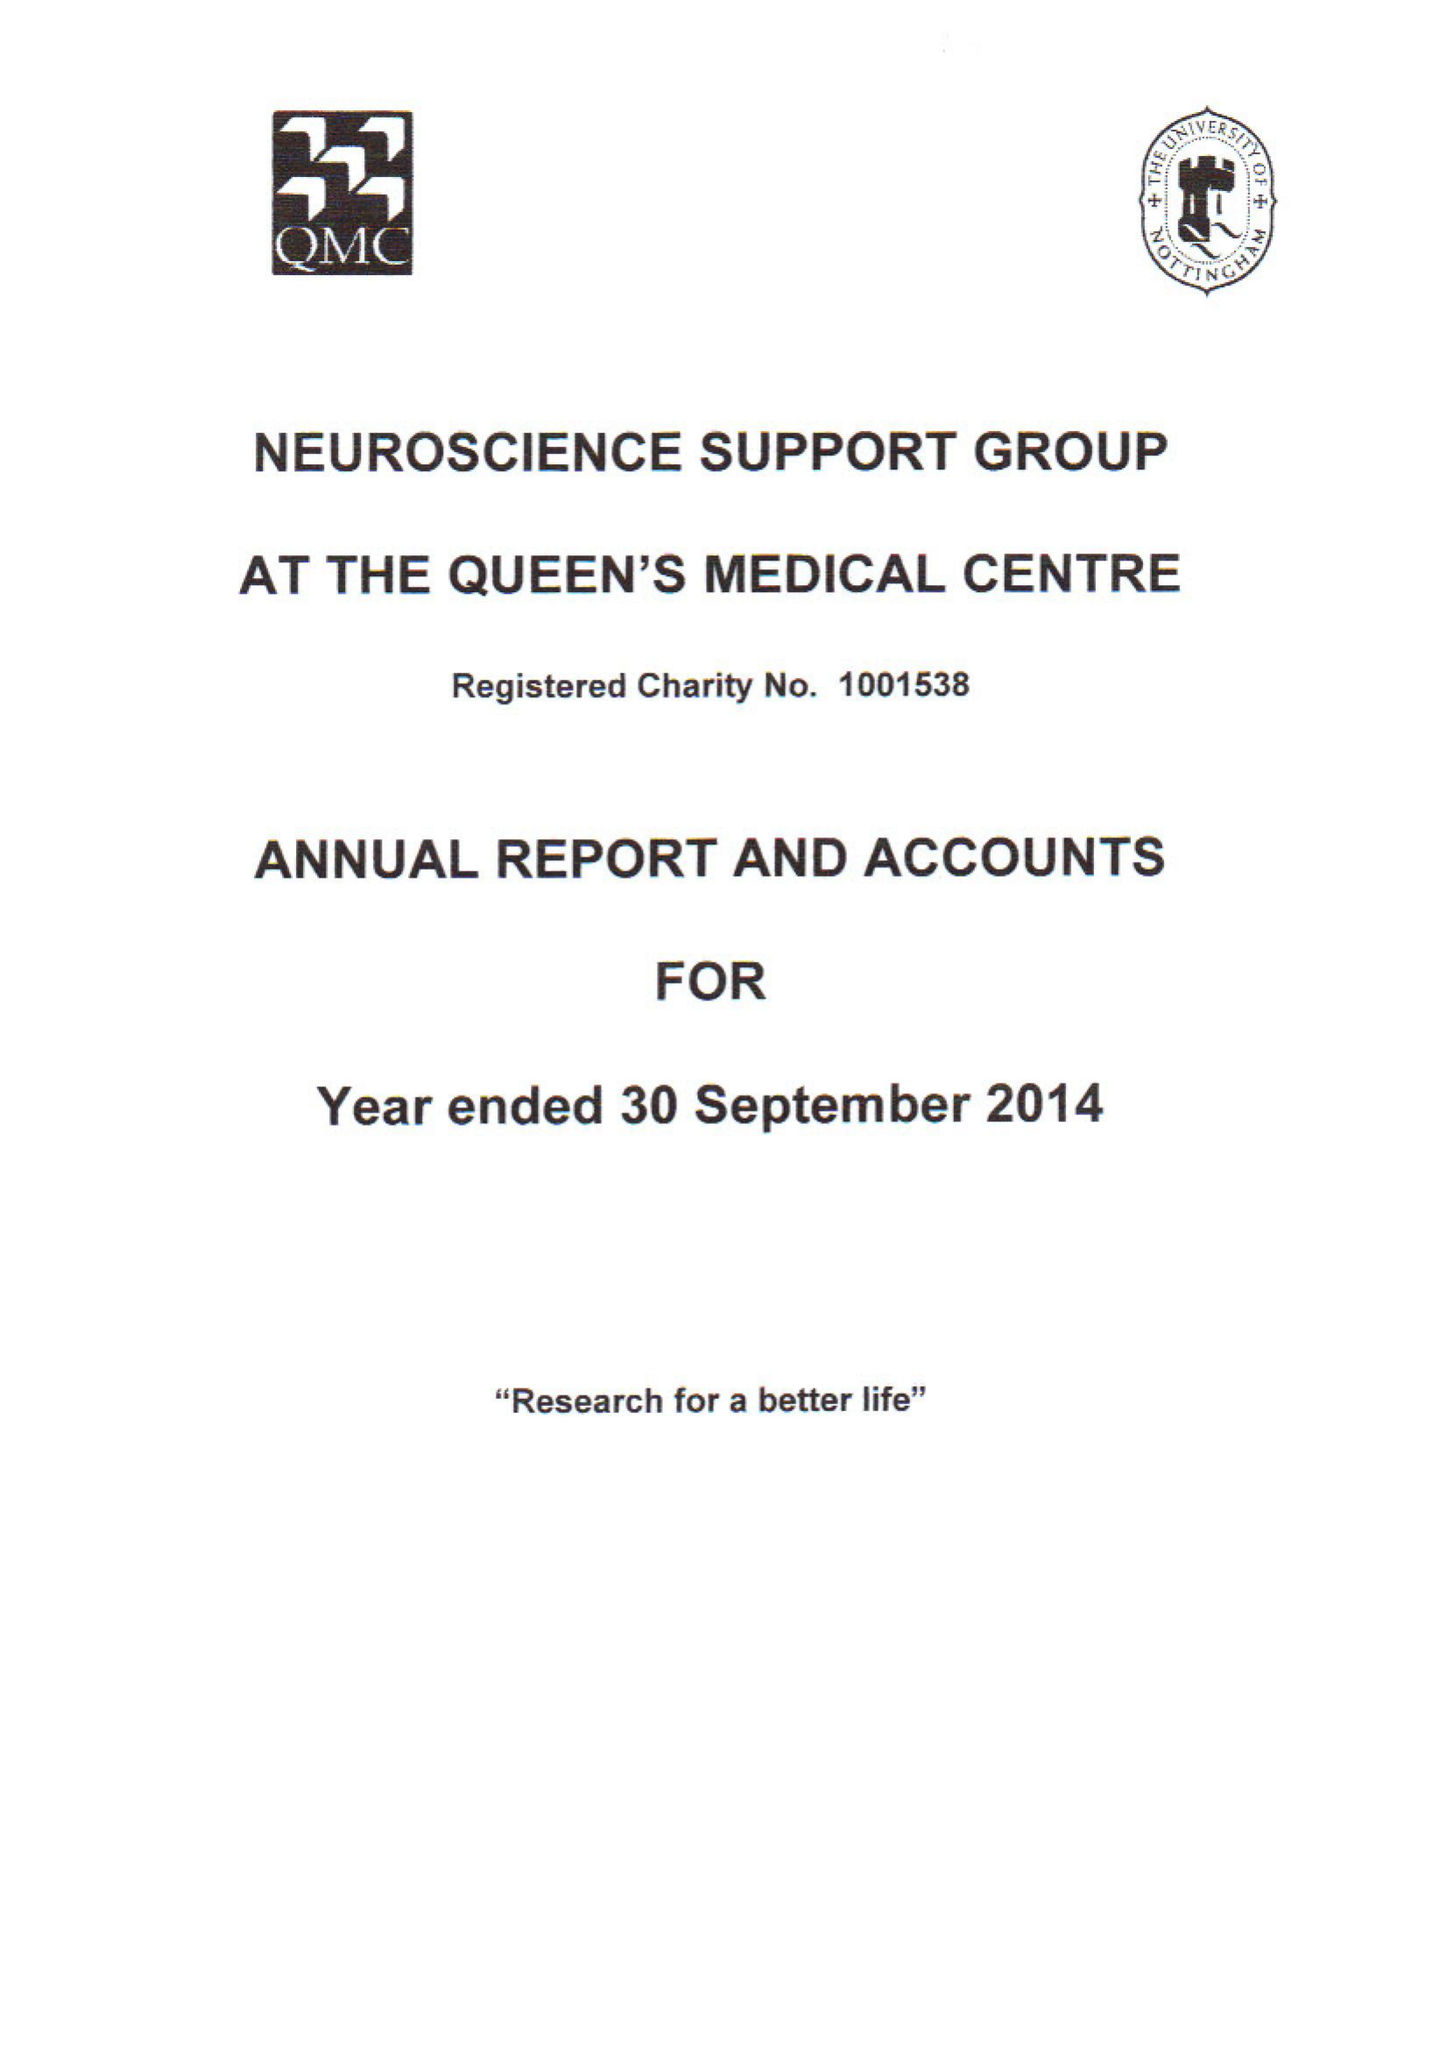What is the value for the spending_annually_in_british_pounds?
Answer the question using a single word or phrase. 25003.00 